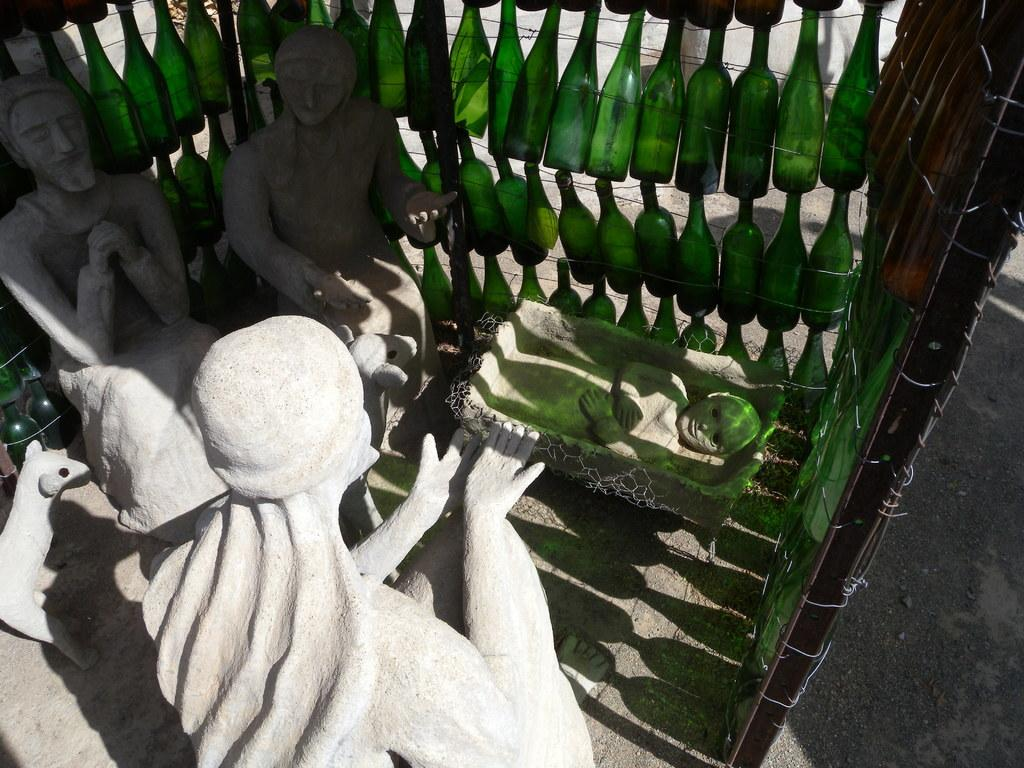What type of artwork is present in the image? There are sculptures in the image. Where are the sculptures located in the image? The sculptures are in the front of the image. What other objects can be seen in the image? There are bottles in the image. Where are the bottles located in the image? The bottles are in the middle of the image. What type of thread is used to create the dress on the sculpture in the image? There is no dress present on the sculptures in the image, so it is not possible to determine the type of thread used. 